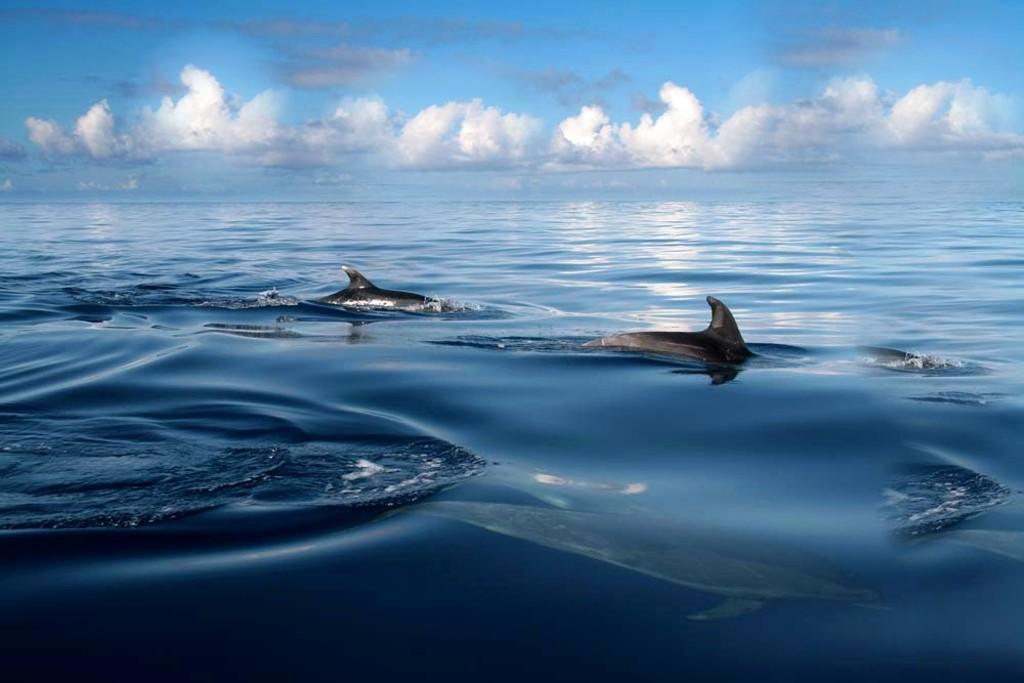What is at the bottom of the image? There is water at the bottom of the image. What can be found swimming in the water? There are two fishes in the water. What is visible in the sky at the top of the image? There are clouds in the sky at the top of the image. What type of trousers can be seen hanging on the fowl in the image? There are no trousers or fowls present in the image; it features water with two fishes and clouds in the sky. 